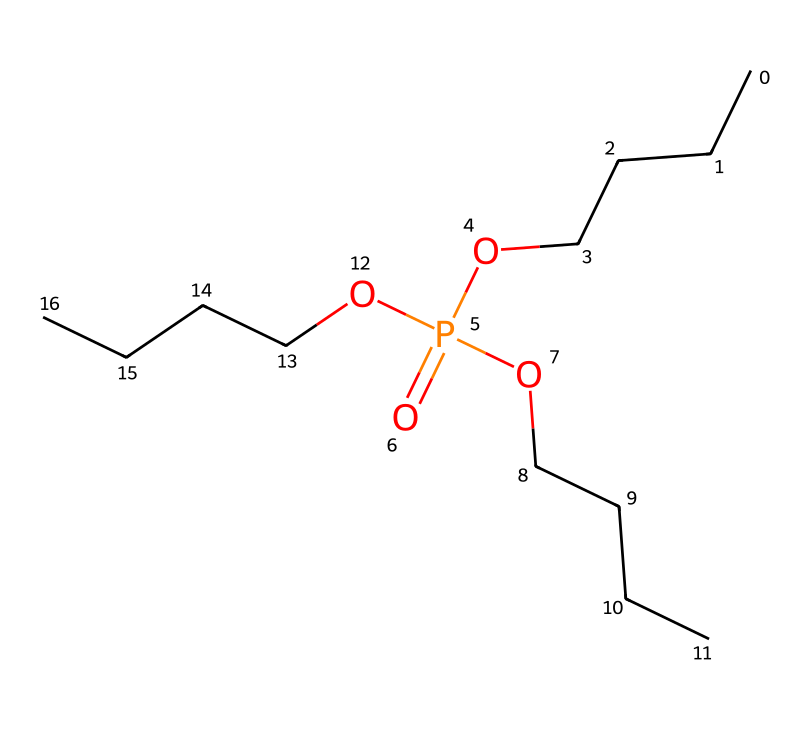What is the central atom in tributyl phosphate? The structure contains phosphorus (P) at the center, as indicated by its position within the phosphate group connected to the carbon chains.
Answer: phosphorus How many carbon atoms are present in tributyl phosphate? The chemical has four carbon atoms in each butyl group, and there are three butyl groups, hence 4 x 3 = 12.
Answer: twelve How many oxygen atoms are found in tributyl phosphate? There are four oxygen atoms indicated in the formula, corresponding to the phosphate structure with three -O groups and one =O group.
Answer: four What type of compound is tributyl phosphate? The presence of the phosphorus atom bonded to oxygen and carbon groups indicates this compound is an organophosphate.
Answer: organophosphate What functional group is present in tributyl phosphate? The phosphate group (PO4) structure reveals the presence of this functional group, specifically denoted by its phosphorous bonded with oxygen.
Answer: phosphate How many butyl groups are present in tributyl phosphate? Each tributyl phosphate molecule has three butyl groups, as indicated by the 'tributyl' in the name and their representation in the SMILES notation.
Answer: three What role does tributyl phosphate play in materials used on film sets? Tributyl phosphate is primarily used as a flame retardant in materials to prevent ignition and protect against fire hazards.
Answer: flame retardant 